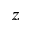Convert formula to latex. <formula><loc_0><loc_0><loc_500><loc_500>z</formula> 